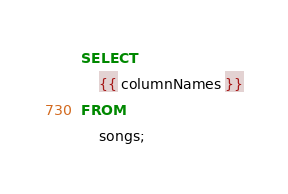<code> <loc_0><loc_0><loc_500><loc_500><_SQL_>SELECT
	{{ columnNames }}
FROM
	songs;</code> 